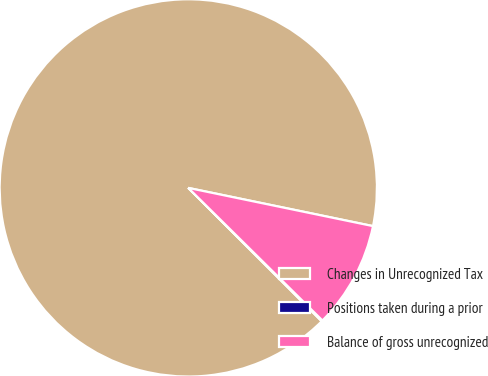Convert chart. <chart><loc_0><loc_0><loc_500><loc_500><pie_chart><fcel>Changes in Unrecognized Tax<fcel>Positions taken during a prior<fcel>Balance of gross unrecognized<nl><fcel>90.75%<fcel>0.09%<fcel>9.16%<nl></chart> 